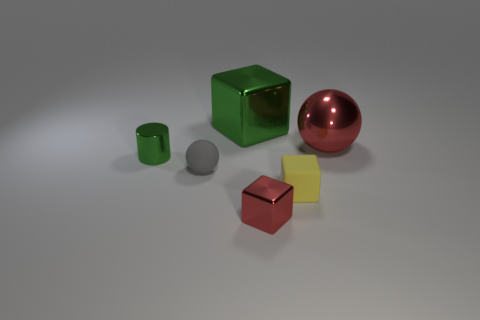Is the color of the small object in front of the yellow matte cube the same as the shiny ball?
Make the answer very short. Yes. What is the size of the shiny object that is the same color as the metallic ball?
Provide a short and direct response. Small. What material is the tiny cylinder that is the same color as the big shiny block?
Make the answer very short. Metal. Do the large thing that is behind the large ball and the small object behind the small gray ball have the same color?
Keep it short and to the point. Yes. What number of other objects are the same color as the tiny matte cube?
Offer a very short reply. 0. There is a ball in front of the green metallic object that is on the left side of the green block; what is its material?
Give a very brief answer. Rubber. Is the number of shiny objects left of the tiny yellow block greater than the number of tiny brown blocks?
Offer a terse response. Yes. What number of green things are the same size as the red shiny sphere?
Your answer should be very brief. 1. Does the sphere that is to the left of the tiny metallic cube have the same size as the green thing that is to the right of the tiny rubber sphere?
Offer a terse response. No. What size is the red shiny thing in front of the tiny ball?
Make the answer very short. Small. 